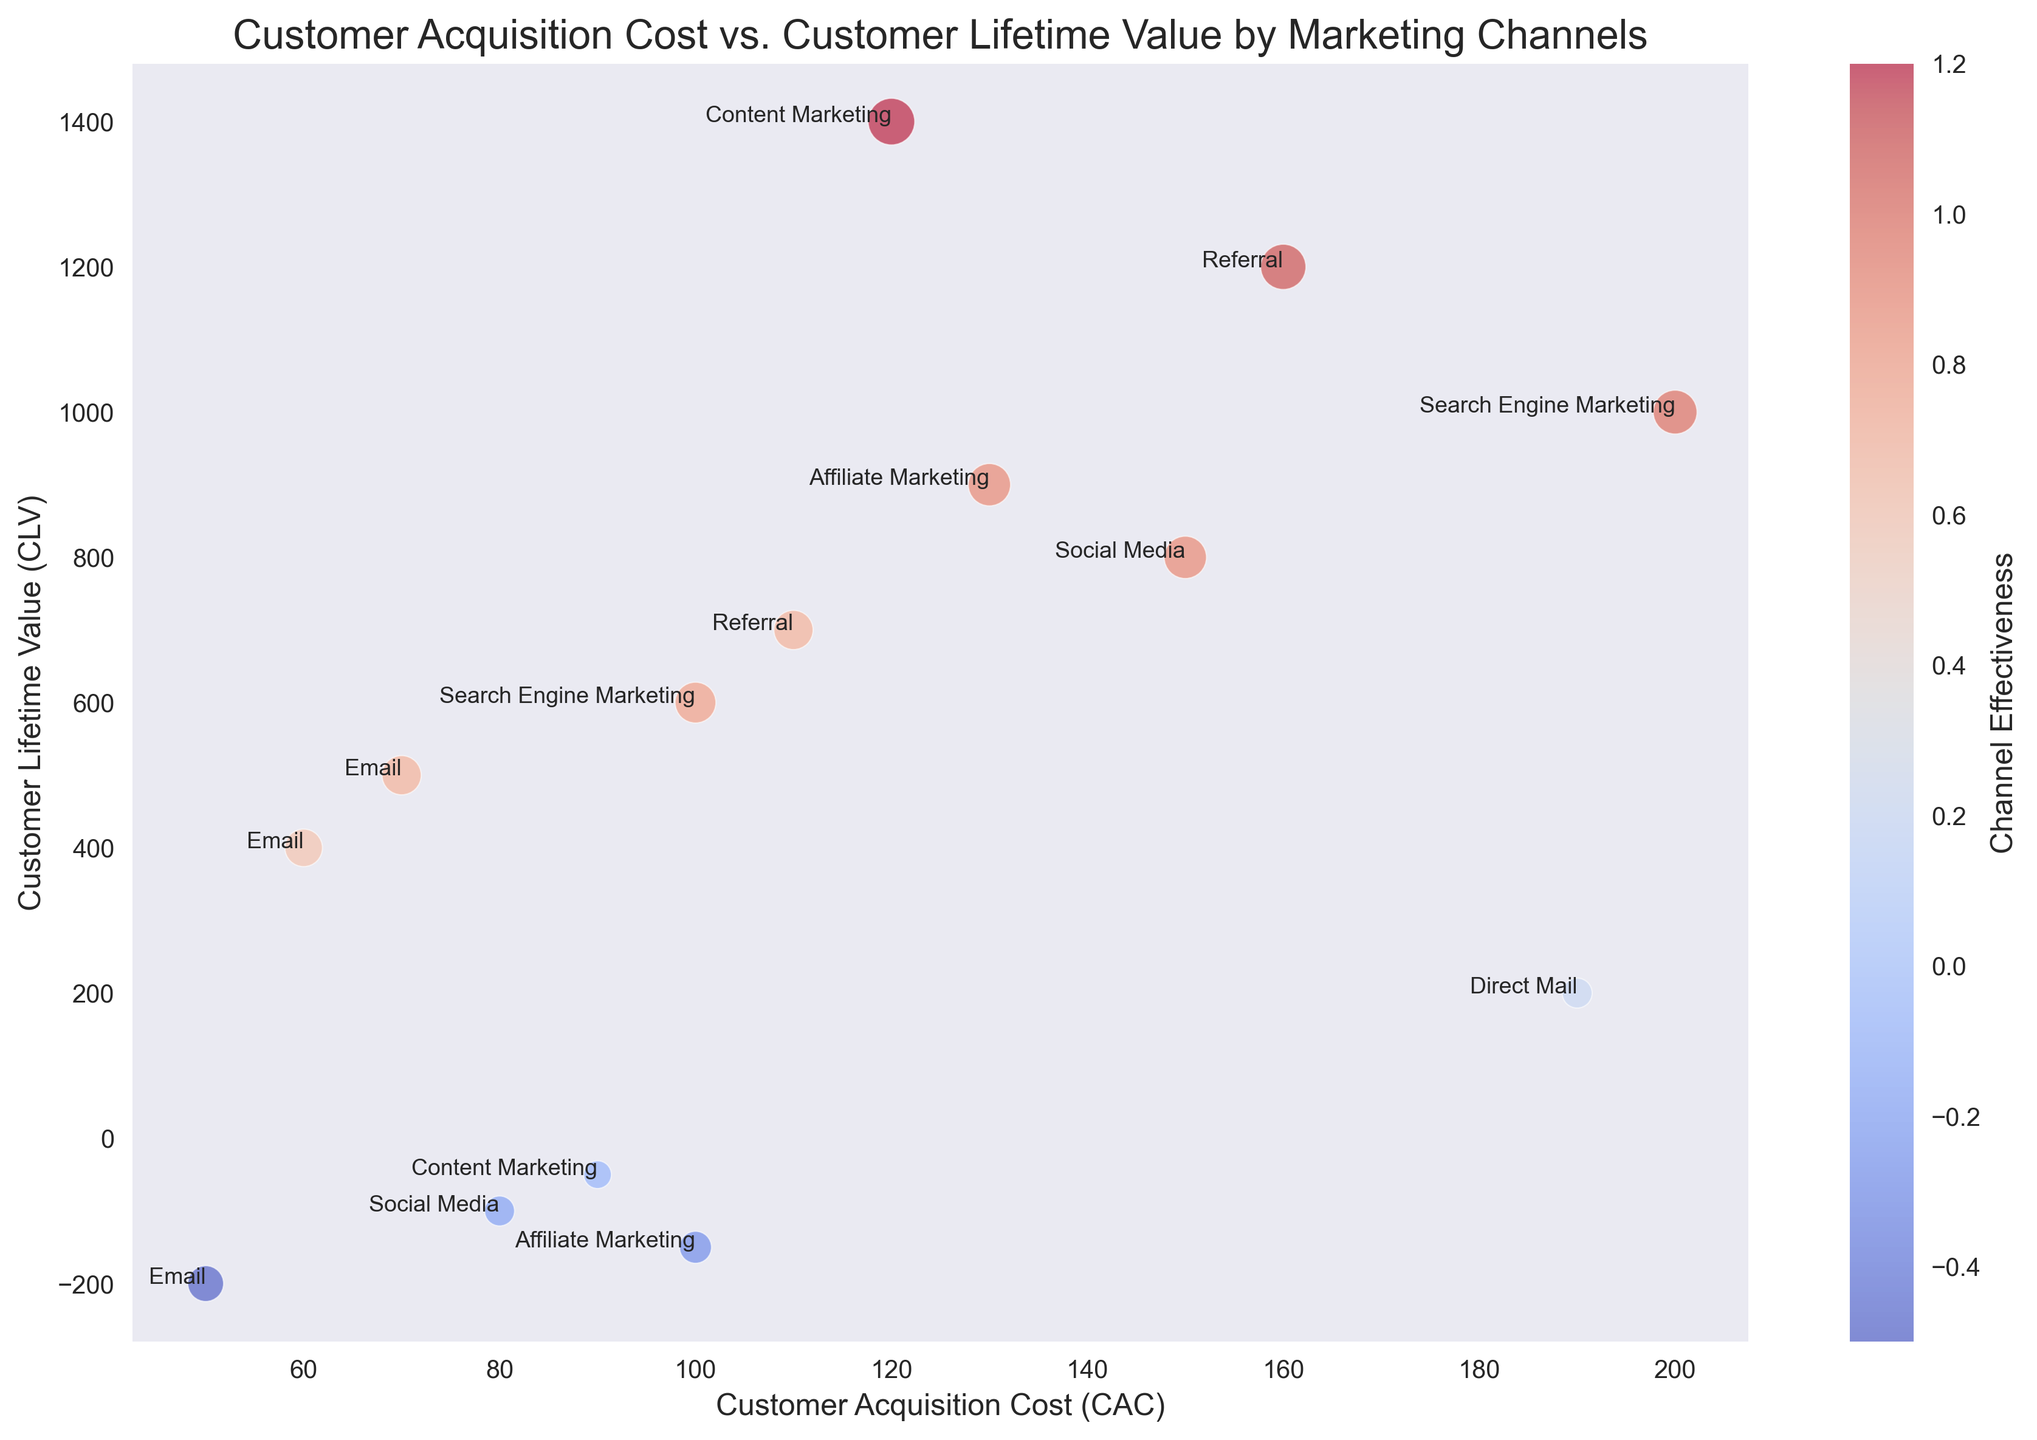What channel has the highest Customer Lifetime Value (CLV)? To find the channel with the highest CLV, look at the vertical axis (CLV) and identify the point with the maximum value. Here, Content Marketing has the highest CLV at 1400.
Answer: Content Marketing Which marketing channel has the lowest Customer Acquisition Cost (CAC)? To identify the channel with the lowest CAC, look at the horizontal axis (CAC) and find the point with the minimum value. Here, the lowest CAC is 50, which belongs to Email.
Answer: Email Which marketing channel has a negative CLV and what is its associated effectiveness? Points with a negative CLV are below the zero line on the vertical axis. There are multiple channels with negative CLV: Email at -200, Social Media at -100, Content Marketing at -50, and Affiliate Marketing at -150. Their respective effectiveness values are -0.5, -0.2, -0.1, and -0.3.
Answer: Email (-0.5), Social Media (-0.2), Content Marketing (-0.1), Affiliate Marketing (-0.3) What is the difference in CLV between the Email and Search Engine Marketing channels with the highest CLVs? First, find the CLV for Email (highest is 500) and Search Engine Marketing (1000). Subtract the Email value from the Search Engine Marketing value: 1000 - 500 = 500.
Answer: 500 Compare the effectiveness of Referral and Direct Mail channels. Which one is higher, and by how much? Find the effectiveness of both Referral (0.7 and 1.1) and Direct Mail (0.2). The average or maximum effectiveness can be used here. The highest effectiveness for Referral is 1.1, and for Direct Mail, it is 0.2. Subtract the Direct Mail value from the Referral value: 1.1 - 0.2 = 0.9.
Answer: Referral by 0.9 What is the average Customer Acquisition Cost (CAC) for Social Media channels? To find the average CAC for Social Media, locate the CAC values for Social Media (80 and 150). Calculate the average by summing these values and dividing by 2: (80 + 150) / 2 = 115.
Answer: 115 How many marketing channels have a Channel Effectiveness greater than 1.0? Look at the color bar to identify points with effectiveness greater than 1.0. Here, only one channel, Content Marketing (1.2), meets this criterion.
Answer: 1 Which has a greater CLV: the least effective Email point or the most effective Affiliate Marketing point? The least effective Email point has a CLV of -200, and the most effective Affiliate Marketing point has a CLV of 900. Compare these values: -200 (Email) versus 900 (Affiliate Marketing).
Answer: Affiliate Marketing What is the relationship between CAC and CLV for Content Marketing? Look at the points related to Content Marketing. One has a high CLV (1400) and moderate CAC (120), while the other has a low CLV (-50) and a lower CAC (90). There’s no clear trend as these two points vary significantly.
Answer: No clear relationship 